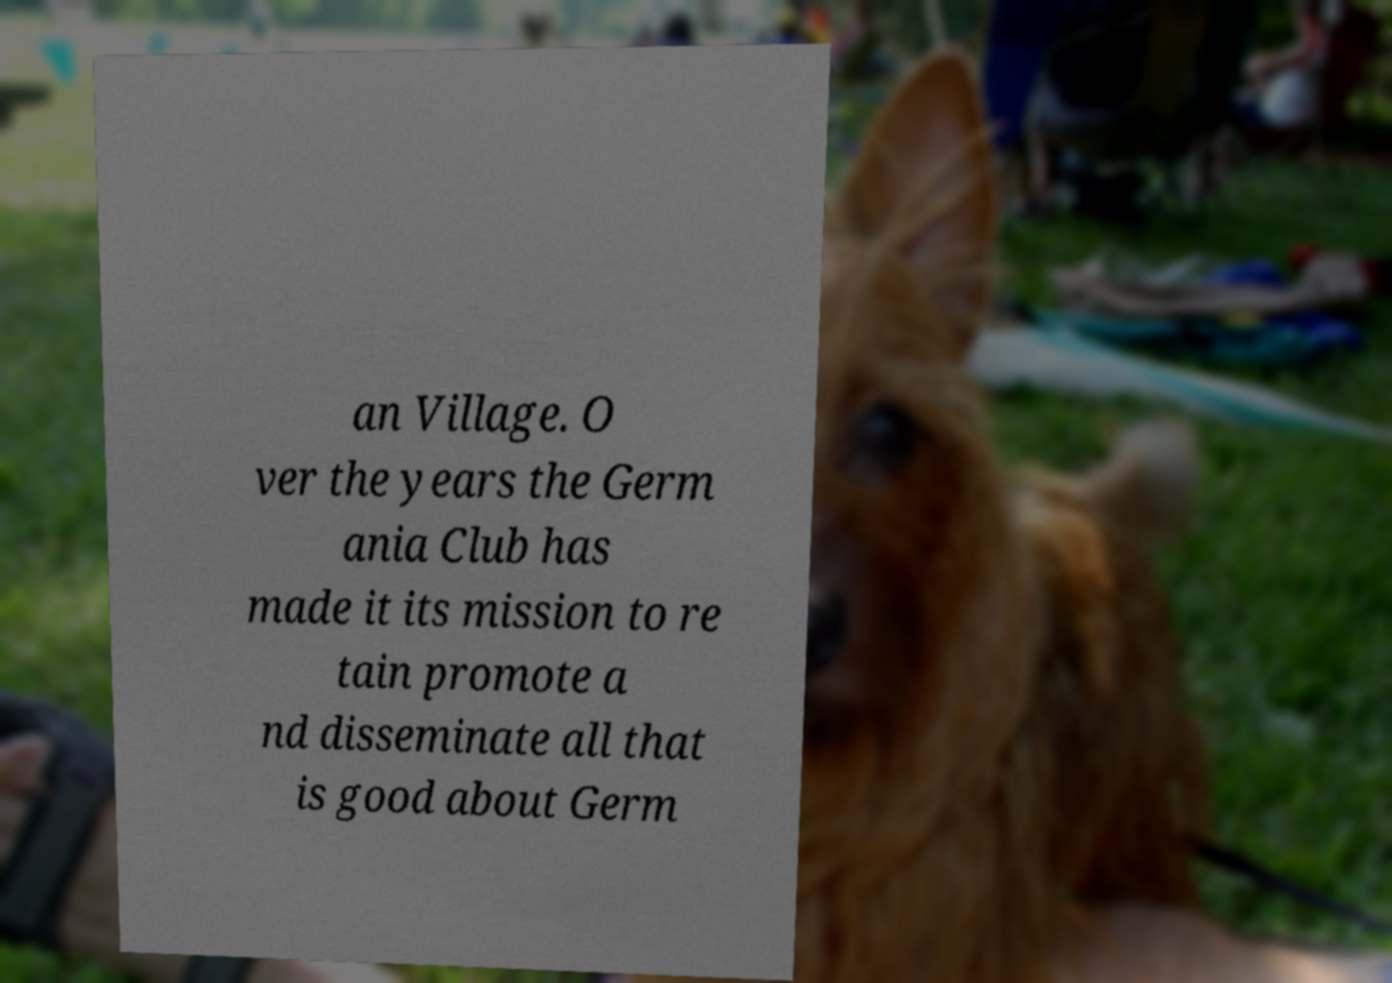There's text embedded in this image that I need extracted. Can you transcribe it verbatim? an Village. O ver the years the Germ ania Club has made it its mission to re tain promote a nd disseminate all that is good about Germ 